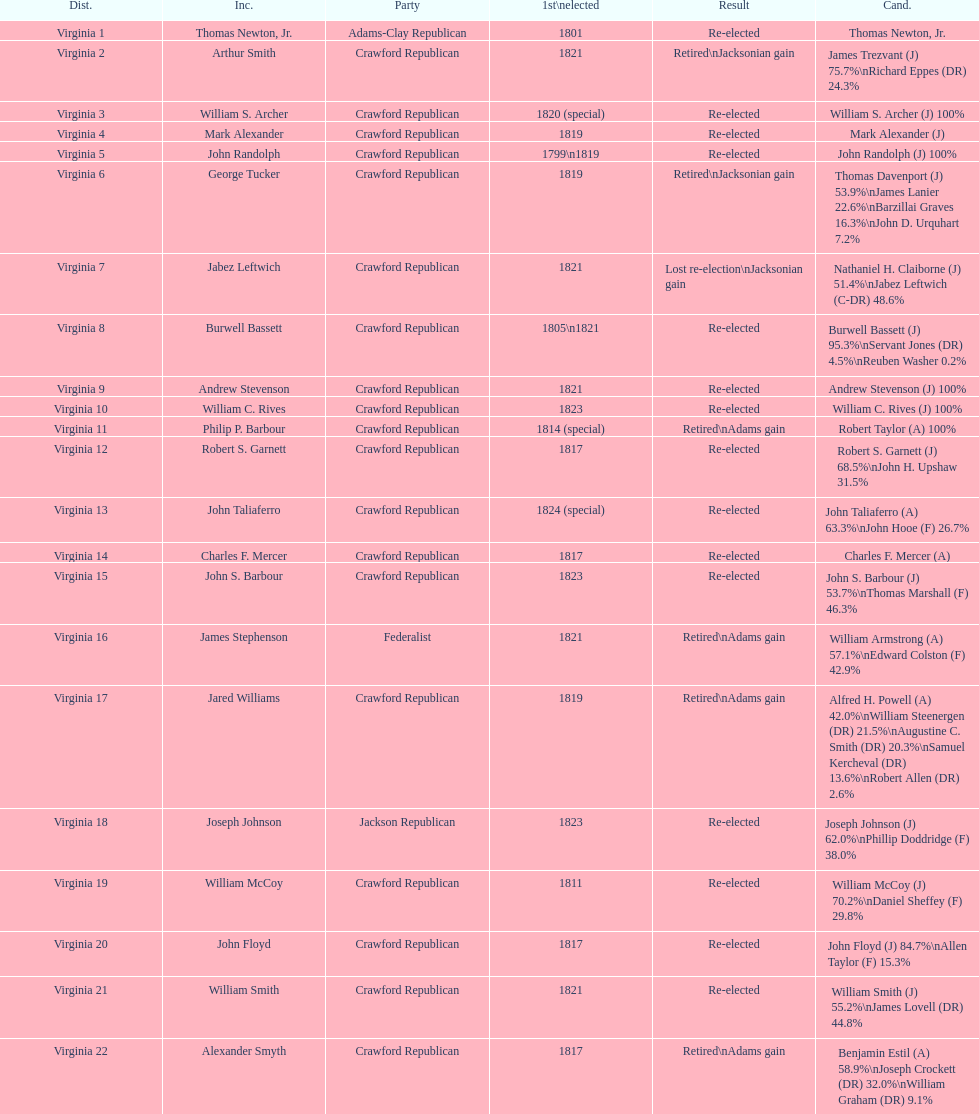Who was the next incumbent after john randolph? George Tucker. 